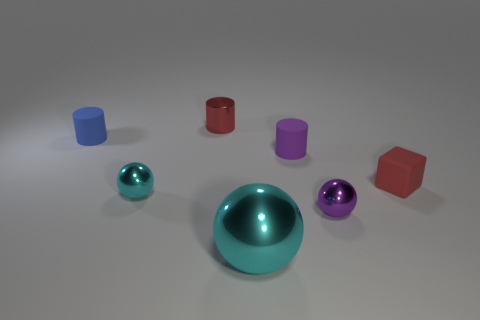What could be the function of these objects if they were real? If these objects were real, they could serve various purposes. The cylinders might be containers or parts of a children's building toy set, due to their size and shape. The spheres could be decorative, as they're smooth and eye-catching, potentially used as paperweights or elements in a game. How do the shadows in the image help us understand the environment? The shadows cast by the objects suggest a single light source coming from the upper left of the frame, possibly mimicking natural light. They are soft but distinct, indicating the surface is flat and the ambient environment is diffuse, likely an indoor setting with indirect lighting. The shadows help to give the objects a sense of depth and placement within the space. 